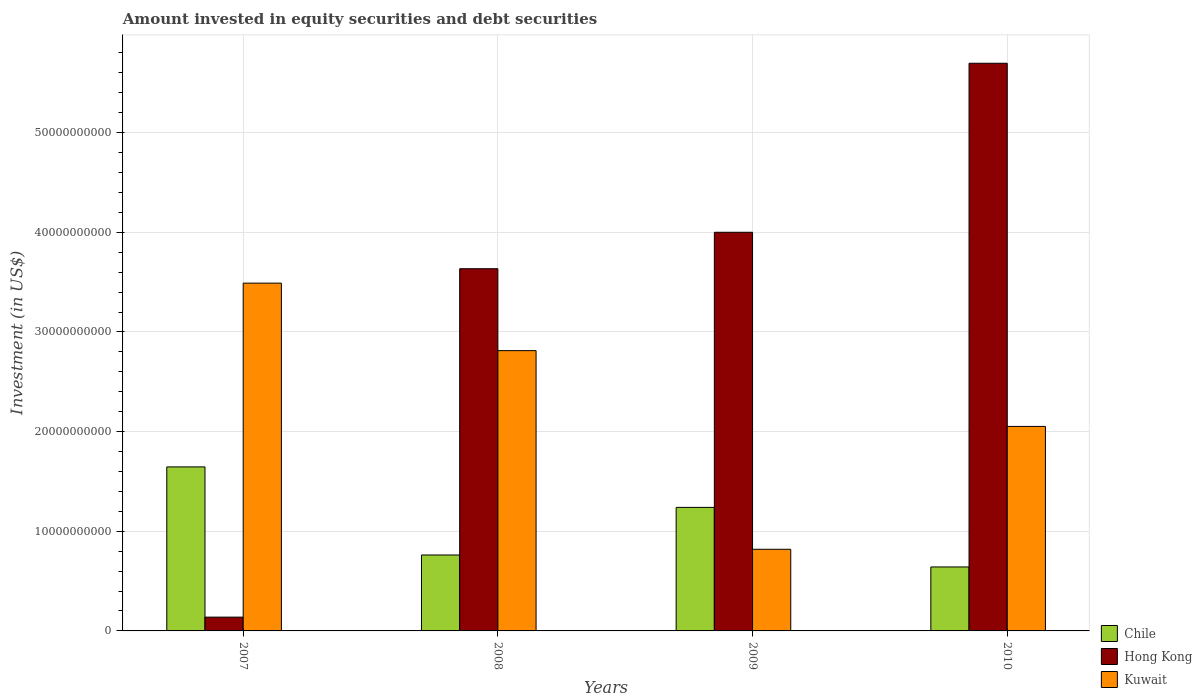How many groups of bars are there?
Provide a succinct answer. 4. Are the number of bars on each tick of the X-axis equal?
Offer a very short reply. Yes. How many bars are there on the 4th tick from the right?
Offer a terse response. 3. What is the label of the 4th group of bars from the left?
Offer a very short reply. 2010. What is the amount invested in equity securities and debt securities in Kuwait in 2010?
Make the answer very short. 2.05e+1. Across all years, what is the maximum amount invested in equity securities and debt securities in Chile?
Make the answer very short. 1.65e+1. Across all years, what is the minimum amount invested in equity securities and debt securities in Hong Kong?
Offer a very short reply. 1.38e+09. What is the total amount invested in equity securities and debt securities in Hong Kong in the graph?
Your answer should be very brief. 1.35e+11. What is the difference between the amount invested in equity securities and debt securities in Hong Kong in 2007 and that in 2009?
Keep it short and to the point. -3.86e+1. What is the difference between the amount invested in equity securities and debt securities in Kuwait in 2008 and the amount invested in equity securities and debt securities in Chile in 2010?
Offer a terse response. 2.17e+1. What is the average amount invested in equity securities and debt securities in Chile per year?
Offer a terse response. 1.07e+1. In the year 2009, what is the difference between the amount invested in equity securities and debt securities in Kuwait and amount invested in equity securities and debt securities in Hong Kong?
Provide a short and direct response. -3.18e+1. What is the ratio of the amount invested in equity securities and debt securities in Kuwait in 2007 to that in 2008?
Give a very brief answer. 1.24. Is the amount invested in equity securities and debt securities in Kuwait in 2007 less than that in 2009?
Give a very brief answer. No. Is the difference between the amount invested in equity securities and debt securities in Kuwait in 2007 and 2009 greater than the difference between the amount invested in equity securities and debt securities in Hong Kong in 2007 and 2009?
Give a very brief answer. Yes. What is the difference between the highest and the second highest amount invested in equity securities and debt securities in Chile?
Your answer should be very brief. 4.06e+09. What is the difference between the highest and the lowest amount invested in equity securities and debt securities in Hong Kong?
Provide a short and direct response. 5.56e+1. In how many years, is the amount invested in equity securities and debt securities in Chile greater than the average amount invested in equity securities and debt securities in Chile taken over all years?
Your response must be concise. 2. Is the sum of the amount invested in equity securities and debt securities in Chile in 2007 and 2010 greater than the maximum amount invested in equity securities and debt securities in Hong Kong across all years?
Your answer should be very brief. No. What does the 3rd bar from the right in 2009 represents?
Offer a very short reply. Chile. Is it the case that in every year, the sum of the amount invested in equity securities and debt securities in Kuwait and amount invested in equity securities and debt securities in Hong Kong is greater than the amount invested in equity securities and debt securities in Chile?
Your response must be concise. Yes. How many years are there in the graph?
Offer a terse response. 4. What is the difference between two consecutive major ticks on the Y-axis?
Your response must be concise. 1.00e+1. Does the graph contain any zero values?
Offer a very short reply. No. Does the graph contain grids?
Your response must be concise. Yes. What is the title of the graph?
Offer a terse response. Amount invested in equity securities and debt securities. Does "Nicaragua" appear as one of the legend labels in the graph?
Offer a very short reply. No. What is the label or title of the X-axis?
Your answer should be very brief. Years. What is the label or title of the Y-axis?
Offer a terse response. Investment (in US$). What is the Investment (in US$) in Chile in 2007?
Your answer should be very brief. 1.65e+1. What is the Investment (in US$) of Hong Kong in 2007?
Ensure brevity in your answer.  1.38e+09. What is the Investment (in US$) in Kuwait in 2007?
Your response must be concise. 3.49e+1. What is the Investment (in US$) in Chile in 2008?
Keep it short and to the point. 7.62e+09. What is the Investment (in US$) in Hong Kong in 2008?
Keep it short and to the point. 3.63e+1. What is the Investment (in US$) in Kuwait in 2008?
Offer a very short reply. 2.81e+1. What is the Investment (in US$) in Chile in 2009?
Your answer should be very brief. 1.24e+1. What is the Investment (in US$) in Hong Kong in 2009?
Give a very brief answer. 4.00e+1. What is the Investment (in US$) of Kuwait in 2009?
Give a very brief answer. 8.19e+09. What is the Investment (in US$) in Chile in 2010?
Provide a short and direct response. 6.42e+09. What is the Investment (in US$) in Hong Kong in 2010?
Ensure brevity in your answer.  5.70e+1. What is the Investment (in US$) in Kuwait in 2010?
Make the answer very short. 2.05e+1. Across all years, what is the maximum Investment (in US$) of Chile?
Your answer should be compact. 1.65e+1. Across all years, what is the maximum Investment (in US$) in Hong Kong?
Make the answer very short. 5.70e+1. Across all years, what is the maximum Investment (in US$) of Kuwait?
Provide a short and direct response. 3.49e+1. Across all years, what is the minimum Investment (in US$) of Chile?
Ensure brevity in your answer.  6.42e+09. Across all years, what is the minimum Investment (in US$) in Hong Kong?
Offer a terse response. 1.38e+09. Across all years, what is the minimum Investment (in US$) in Kuwait?
Ensure brevity in your answer.  8.19e+09. What is the total Investment (in US$) in Chile in the graph?
Your response must be concise. 4.29e+1. What is the total Investment (in US$) in Hong Kong in the graph?
Your answer should be compact. 1.35e+11. What is the total Investment (in US$) of Kuwait in the graph?
Keep it short and to the point. 9.18e+1. What is the difference between the Investment (in US$) in Chile in 2007 and that in 2008?
Provide a succinct answer. 8.84e+09. What is the difference between the Investment (in US$) of Hong Kong in 2007 and that in 2008?
Your answer should be compact. -3.50e+1. What is the difference between the Investment (in US$) in Kuwait in 2007 and that in 2008?
Make the answer very short. 6.77e+09. What is the difference between the Investment (in US$) in Chile in 2007 and that in 2009?
Your response must be concise. 4.06e+09. What is the difference between the Investment (in US$) in Hong Kong in 2007 and that in 2009?
Give a very brief answer. -3.86e+1. What is the difference between the Investment (in US$) of Kuwait in 2007 and that in 2009?
Your answer should be compact. 2.67e+1. What is the difference between the Investment (in US$) of Chile in 2007 and that in 2010?
Ensure brevity in your answer.  1.00e+1. What is the difference between the Investment (in US$) of Hong Kong in 2007 and that in 2010?
Keep it short and to the point. -5.56e+1. What is the difference between the Investment (in US$) of Kuwait in 2007 and that in 2010?
Provide a succinct answer. 1.44e+1. What is the difference between the Investment (in US$) in Chile in 2008 and that in 2009?
Your answer should be very brief. -4.78e+09. What is the difference between the Investment (in US$) in Hong Kong in 2008 and that in 2009?
Provide a short and direct response. -3.66e+09. What is the difference between the Investment (in US$) in Kuwait in 2008 and that in 2009?
Offer a very short reply. 1.99e+1. What is the difference between the Investment (in US$) of Chile in 2008 and that in 2010?
Offer a very short reply. 1.20e+09. What is the difference between the Investment (in US$) of Hong Kong in 2008 and that in 2010?
Provide a succinct answer. -2.06e+1. What is the difference between the Investment (in US$) of Kuwait in 2008 and that in 2010?
Provide a succinct answer. 7.61e+09. What is the difference between the Investment (in US$) in Chile in 2009 and that in 2010?
Ensure brevity in your answer.  5.98e+09. What is the difference between the Investment (in US$) of Hong Kong in 2009 and that in 2010?
Make the answer very short. -1.70e+1. What is the difference between the Investment (in US$) of Kuwait in 2009 and that in 2010?
Your answer should be very brief. -1.23e+1. What is the difference between the Investment (in US$) in Chile in 2007 and the Investment (in US$) in Hong Kong in 2008?
Provide a short and direct response. -1.99e+1. What is the difference between the Investment (in US$) of Chile in 2007 and the Investment (in US$) of Kuwait in 2008?
Your answer should be compact. -1.17e+1. What is the difference between the Investment (in US$) in Hong Kong in 2007 and the Investment (in US$) in Kuwait in 2008?
Offer a very short reply. -2.67e+1. What is the difference between the Investment (in US$) in Chile in 2007 and the Investment (in US$) in Hong Kong in 2009?
Make the answer very short. -2.35e+1. What is the difference between the Investment (in US$) in Chile in 2007 and the Investment (in US$) in Kuwait in 2009?
Provide a succinct answer. 8.27e+09. What is the difference between the Investment (in US$) of Hong Kong in 2007 and the Investment (in US$) of Kuwait in 2009?
Your response must be concise. -6.81e+09. What is the difference between the Investment (in US$) of Chile in 2007 and the Investment (in US$) of Hong Kong in 2010?
Offer a terse response. -4.05e+1. What is the difference between the Investment (in US$) in Chile in 2007 and the Investment (in US$) in Kuwait in 2010?
Your answer should be compact. -4.06e+09. What is the difference between the Investment (in US$) of Hong Kong in 2007 and the Investment (in US$) of Kuwait in 2010?
Ensure brevity in your answer.  -1.91e+1. What is the difference between the Investment (in US$) of Chile in 2008 and the Investment (in US$) of Hong Kong in 2009?
Your answer should be very brief. -3.24e+1. What is the difference between the Investment (in US$) of Chile in 2008 and the Investment (in US$) of Kuwait in 2009?
Your response must be concise. -5.75e+08. What is the difference between the Investment (in US$) of Hong Kong in 2008 and the Investment (in US$) of Kuwait in 2009?
Make the answer very short. 2.82e+1. What is the difference between the Investment (in US$) in Chile in 2008 and the Investment (in US$) in Hong Kong in 2010?
Your answer should be compact. -4.94e+1. What is the difference between the Investment (in US$) of Chile in 2008 and the Investment (in US$) of Kuwait in 2010?
Provide a succinct answer. -1.29e+1. What is the difference between the Investment (in US$) of Hong Kong in 2008 and the Investment (in US$) of Kuwait in 2010?
Ensure brevity in your answer.  1.58e+1. What is the difference between the Investment (in US$) of Chile in 2009 and the Investment (in US$) of Hong Kong in 2010?
Your answer should be very brief. -4.46e+1. What is the difference between the Investment (in US$) in Chile in 2009 and the Investment (in US$) in Kuwait in 2010?
Your answer should be very brief. -8.13e+09. What is the difference between the Investment (in US$) in Hong Kong in 2009 and the Investment (in US$) in Kuwait in 2010?
Provide a succinct answer. 1.95e+1. What is the average Investment (in US$) of Chile per year?
Provide a short and direct response. 1.07e+1. What is the average Investment (in US$) in Hong Kong per year?
Your answer should be compact. 3.37e+1. What is the average Investment (in US$) in Kuwait per year?
Give a very brief answer. 2.29e+1. In the year 2007, what is the difference between the Investment (in US$) of Chile and Investment (in US$) of Hong Kong?
Provide a short and direct response. 1.51e+1. In the year 2007, what is the difference between the Investment (in US$) of Chile and Investment (in US$) of Kuwait?
Ensure brevity in your answer.  -1.84e+1. In the year 2007, what is the difference between the Investment (in US$) in Hong Kong and Investment (in US$) in Kuwait?
Make the answer very short. -3.35e+1. In the year 2008, what is the difference between the Investment (in US$) in Chile and Investment (in US$) in Hong Kong?
Your answer should be compact. -2.87e+1. In the year 2008, what is the difference between the Investment (in US$) of Chile and Investment (in US$) of Kuwait?
Offer a terse response. -2.05e+1. In the year 2008, what is the difference between the Investment (in US$) of Hong Kong and Investment (in US$) of Kuwait?
Provide a short and direct response. 8.22e+09. In the year 2009, what is the difference between the Investment (in US$) of Chile and Investment (in US$) of Hong Kong?
Make the answer very short. -2.76e+1. In the year 2009, what is the difference between the Investment (in US$) in Chile and Investment (in US$) in Kuwait?
Your response must be concise. 4.20e+09. In the year 2009, what is the difference between the Investment (in US$) in Hong Kong and Investment (in US$) in Kuwait?
Your answer should be very brief. 3.18e+1. In the year 2010, what is the difference between the Investment (in US$) of Chile and Investment (in US$) of Hong Kong?
Ensure brevity in your answer.  -5.05e+1. In the year 2010, what is the difference between the Investment (in US$) in Chile and Investment (in US$) in Kuwait?
Offer a terse response. -1.41e+1. In the year 2010, what is the difference between the Investment (in US$) in Hong Kong and Investment (in US$) in Kuwait?
Make the answer very short. 3.64e+1. What is the ratio of the Investment (in US$) of Chile in 2007 to that in 2008?
Offer a very short reply. 2.16. What is the ratio of the Investment (in US$) of Hong Kong in 2007 to that in 2008?
Your answer should be very brief. 0.04. What is the ratio of the Investment (in US$) in Kuwait in 2007 to that in 2008?
Your response must be concise. 1.24. What is the ratio of the Investment (in US$) in Chile in 2007 to that in 2009?
Provide a short and direct response. 1.33. What is the ratio of the Investment (in US$) in Hong Kong in 2007 to that in 2009?
Offer a very short reply. 0.03. What is the ratio of the Investment (in US$) of Kuwait in 2007 to that in 2009?
Make the answer very short. 4.26. What is the ratio of the Investment (in US$) in Chile in 2007 to that in 2010?
Keep it short and to the point. 2.56. What is the ratio of the Investment (in US$) in Hong Kong in 2007 to that in 2010?
Offer a terse response. 0.02. What is the ratio of the Investment (in US$) in Kuwait in 2007 to that in 2010?
Ensure brevity in your answer.  1.7. What is the ratio of the Investment (in US$) of Chile in 2008 to that in 2009?
Your answer should be compact. 0.61. What is the ratio of the Investment (in US$) in Hong Kong in 2008 to that in 2009?
Offer a terse response. 0.91. What is the ratio of the Investment (in US$) of Kuwait in 2008 to that in 2009?
Your answer should be compact. 3.43. What is the ratio of the Investment (in US$) in Chile in 2008 to that in 2010?
Your answer should be compact. 1.19. What is the ratio of the Investment (in US$) in Hong Kong in 2008 to that in 2010?
Give a very brief answer. 0.64. What is the ratio of the Investment (in US$) in Kuwait in 2008 to that in 2010?
Give a very brief answer. 1.37. What is the ratio of the Investment (in US$) of Chile in 2009 to that in 2010?
Ensure brevity in your answer.  1.93. What is the ratio of the Investment (in US$) of Hong Kong in 2009 to that in 2010?
Make the answer very short. 0.7. What is the ratio of the Investment (in US$) of Kuwait in 2009 to that in 2010?
Give a very brief answer. 0.4. What is the difference between the highest and the second highest Investment (in US$) in Chile?
Offer a terse response. 4.06e+09. What is the difference between the highest and the second highest Investment (in US$) in Hong Kong?
Make the answer very short. 1.70e+1. What is the difference between the highest and the second highest Investment (in US$) in Kuwait?
Offer a very short reply. 6.77e+09. What is the difference between the highest and the lowest Investment (in US$) in Chile?
Your answer should be very brief. 1.00e+1. What is the difference between the highest and the lowest Investment (in US$) in Hong Kong?
Your answer should be very brief. 5.56e+1. What is the difference between the highest and the lowest Investment (in US$) of Kuwait?
Offer a terse response. 2.67e+1. 